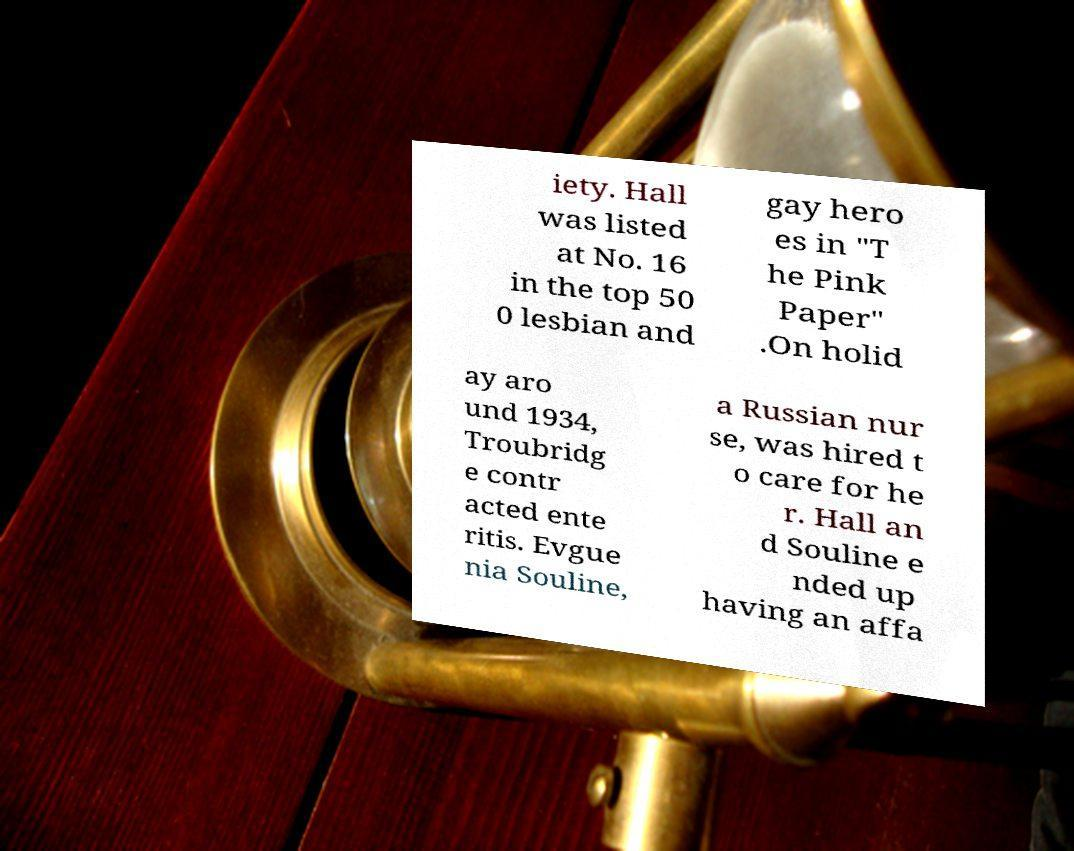Please identify and transcribe the text found in this image. iety. Hall was listed at No. 16 in the top 50 0 lesbian and gay hero es in "T he Pink Paper" .On holid ay aro und 1934, Troubridg e contr acted ente ritis. Evgue nia Souline, a Russian nur se, was hired t o care for he r. Hall an d Souline e nded up having an affa 